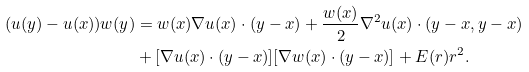<formula> <loc_0><loc_0><loc_500><loc_500>( u ( y ) - u ( x ) ) w ( y ) & = w ( x ) \nabla u ( x ) \cdot ( y - x ) + \frac { w ( x ) } { 2 } \nabla ^ { 2 } u ( x ) \cdot ( y - x , y - x ) \\ & + [ \nabla u ( x ) \cdot ( y - x ) ] [ \nabla w ( x ) \cdot ( y - x ) ] + E ( r ) r ^ { 2 } .</formula> 